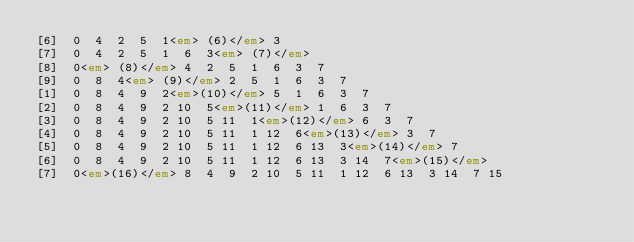Convert code to text. <code><loc_0><loc_0><loc_500><loc_500><_HTML_>[6]  0  4  2  5  1<em> (6)</em> 3 
[7]  0  4  2  5  1  6  3<em> (7)</em>
[8]  0<em> (8)</em> 4  2  5  1  6  3  7 
[9]  0  8  4<em> (9)</em> 2  5  1  6  3  7 
[1]  0  8  4  9  2<em>(10)</em> 5  1  6  3  7 
[2]  0  8  4  9  2 10  5<em>(11)</em> 1  6  3  7 
[3]  0  8  4  9  2 10  5 11  1<em>(12)</em> 6  3  7 
[4]  0  8  4  9  2 10  5 11  1 12  6<em>(13)</em> 3  7 
[5]  0  8  4  9  2 10  5 11  1 12  6 13  3<em>(14)</em> 7 
[6]  0  8  4  9  2 10  5 11  1 12  6 13  3 14  7<em>(15)</em>
[7]  0<em>(16)</em> 8  4  9  2 10  5 11  1 12  6 13  3 14  7 15 </code> 